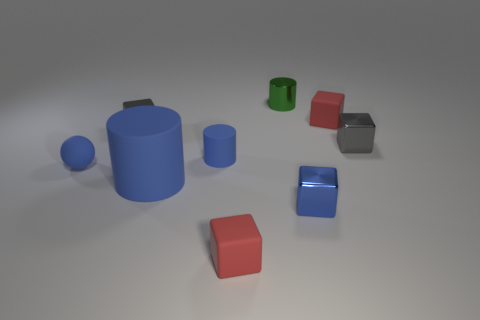Add 3 large brown cylinders. How many large brown cylinders exist? 3 Subtract all green cylinders. How many cylinders are left? 2 Subtract all tiny rubber blocks. How many blocks are left? 3 Subtract 0 purple cylinders. How many objects are left? 9 Subtract all spheres. How many objects are left? 8 Subtract 3 blocks. How many blocks are left? 2 Subtract all yellow cylinders. Subtract all purple cubes. How many cylinders are left? 3 Subtract all gray cylinders. How many red blocks are left? 2 Subtract all big cylinders. Subtract all big blue objects. How many objects are left? 7 Add 5 green metallic things. How many green metallic things are left? 6 